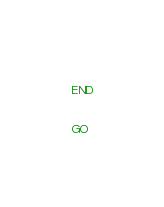<code> <loc_0><loc_0><loc_500><loc_500><_SQL_>	
END


GO


</code> 